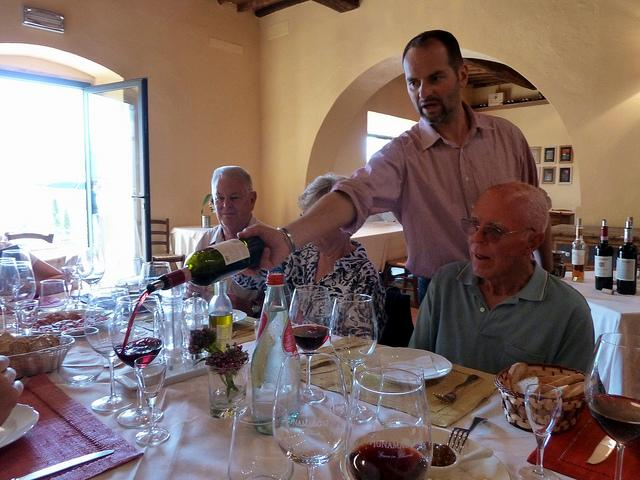From which fruit does the beverage served here come? Please explain your reasoning. grape. Wine is made from grapes. 